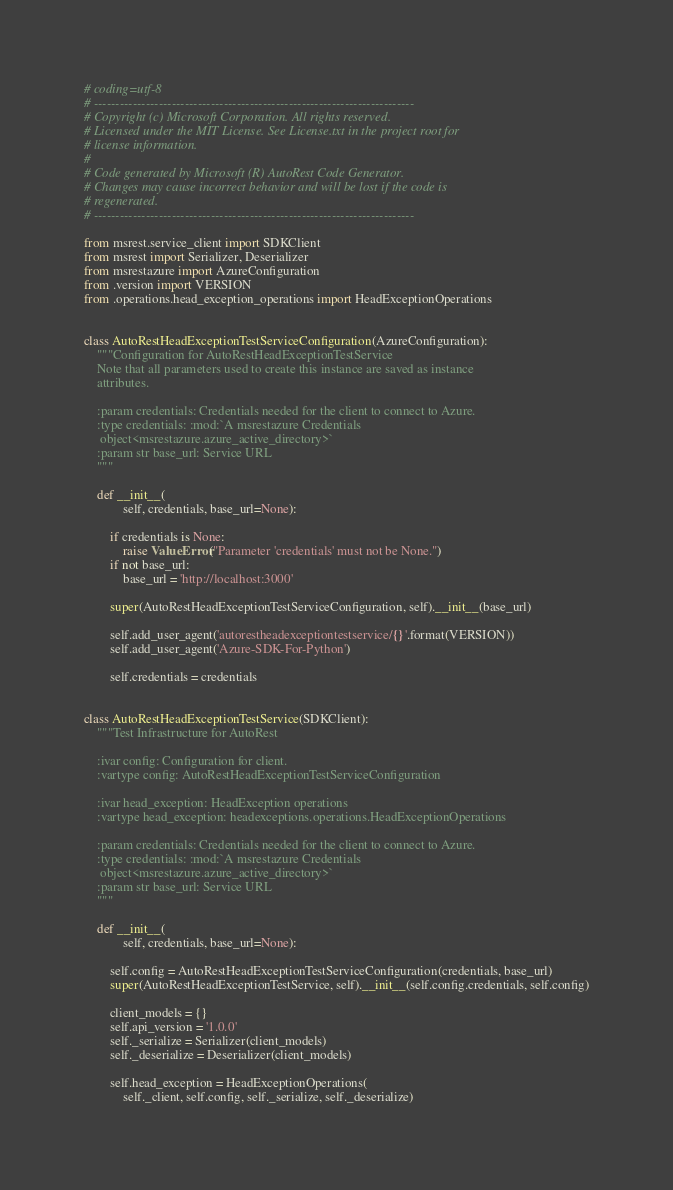<code> <loc_0><loc_0><loc_500><loc_500><_Python_># coding=utf-8
# --------------------------------------------------------------------------
# Copyright (c) Microsoft Corporation. All rights reserved.
# Licensed under the MIT License. See License.txt in the project root for
# license information.
#
# Code generated by Microsoft (R) AutoRest Code Generator.
# Changes may cause incorrect behavior and will be lost if the code is
# regenerated.
# --------------------------------------------------------------------------

from msrest.service_client import SDKClient
from msrest import Serializer, Deserializer
from msrestazure import AzureConfiguration
from .version import VERSION
from .operations.head_exception_operations import HeadExceptionOperations


class AutoRestHeadExceptionTestServiceConfiguration(AzureConfiguration):
    """Configuration for AutoRestHeadExceptionTestService
    Note that all parameters used to create this instance are saved as instance
    attributes.

    :param credentials: Credentials needed for the client to connect to Azure.
    :type credentials: :mod:`A msrestazure Credentials
     object<msrestazure.azure_active_directory>`
    :param str base_url: Service URL
    """

    def __init__(
            self, credentials, base_url=None):

        if credentials is None:
            raise ValueError("Parameter 'credentials' must not be None.")
        if not base_url:
            base_url = 'http://localhost:3000'

        super(AutoRestHeadExceptionTestServiceConfiguration, self).__init__(base_url)

        self.add_user_agent('autorestheadexceptiontestservice/{}'.format(VERSION))
        self.add_user_agent('Azure-SDK-For-Python')

        self.credentials = credentials


class AutoRestHeadExceptionTestService(SDKClient):
    """Test Infrastructure for AutoRest

    :ivar config: Configuration for client.
    :vartype config: AutoRestHeadExceptionTestServiceConfiguration

    :ivar head_exception: HeadException operations
    :vartype head_exception: headexceptions.operations.HeadExceptionOperations

    :param credentials: Credentials needed for the client to connect to Azure.
    :type credentials: :mod:`A msrestazure Credentials
     object<msrestazure.azure_active_directory>`
    :param str base_url: Service URL
    """

    def __init__(
            self, credentials, base_url=None):

        self.config = AutoRestHeadExceptionTestServiceConfiguration(credentials, base_url)
        super(AutoRestHeadExceptionTestService, self).__init__(self.config.credentials, self.config)

        client_models = {}
        self.api_version = '1.0.0'
        self._serialize = Serializer(client_models)
        self._deserialize = Deserializer(client_models)

        self.head_exception = HeadExceptionOperations(
            self._client, self.config, self._serialize, self._deserialize)
</code> 